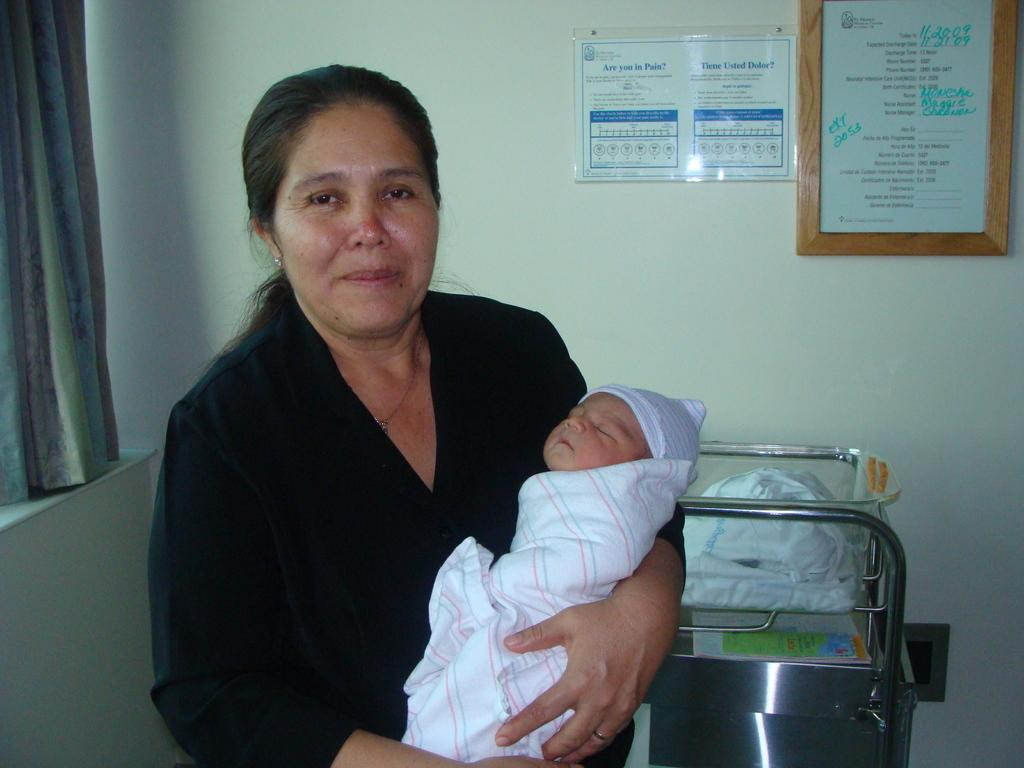<image>
Render a clear and concise summary of the photo. A woman holding a baby in a room with a sign on the wall that says "Are you in pain?" 